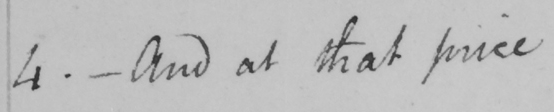Please transcribe the handwritten text in this image. 4 . _  And at that price  _ 